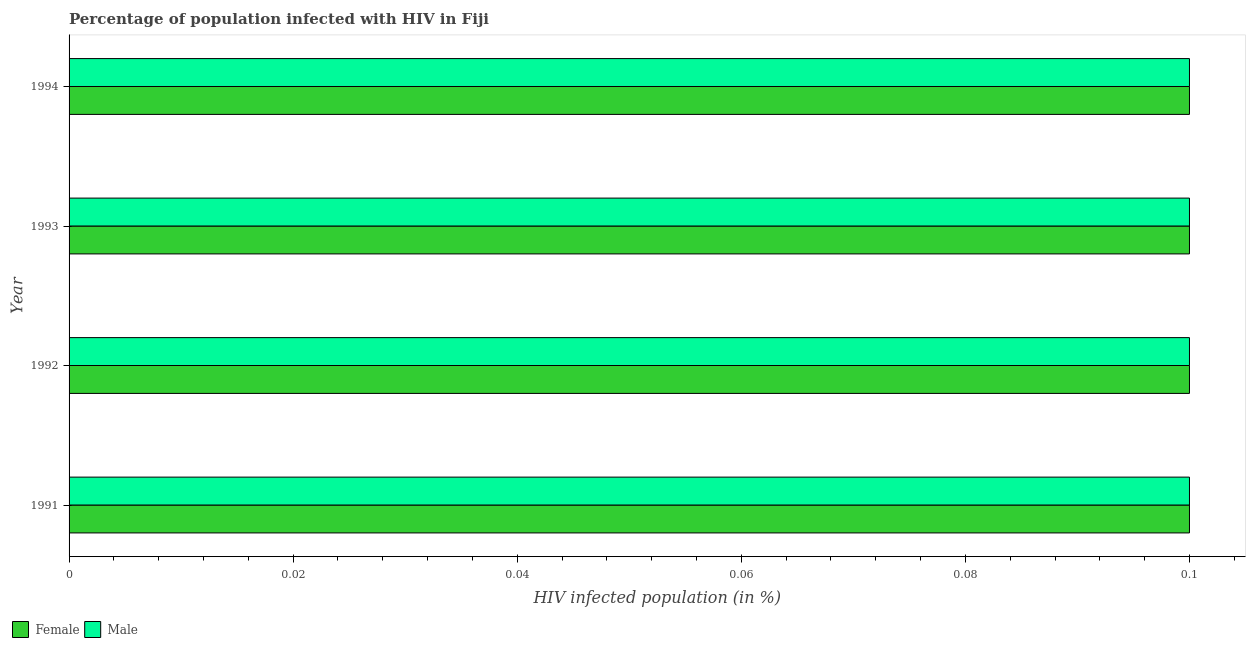How many different coloured bars are there?
Give a very brief answer. 2. Are the number of bars on each tick of the Y-axis equal?
Offer a very short reply. Yes. How many bars are there on the 3rd tick from the top?
Provide a succinct answer. 2. How many bars are there on the 1st tick from the bottom?
Provide a succinct answer. 2. What is the label of the 4th group of bars from the top?
Provide a succinct answer. 1991. In which year was the percentage of males who are infected with hiv minimum?
Ensure brevity in your answer.  1991. What is the total percentage of females who are infected with hiv in the graph?
Your answer should be very brief. 0.4. What is the difference between the percentage of females who are infected with hiv in 1992 and that in 1993?
Your response must be concise. 0. What is the difference between the percentage of females who are infected with hiv in 1994 and the percentage of males who are infected with hiv in 1993?
Give a very brief answer. 0. In the year 1994, what is the difference between the percentage of females who are infected with hiv and percentage of males who are infected with hiv?
Provide a succinct answer. 0. What is the ratio of the percentage of females who are infected with hiv in 1993 to that in 1994?
Give a very brief answer. 1. Is the difference between the percentage of females who are infected with hiv in 1992 and 1993 greater than the difference between the percentage of males who are infected with hiv in 1992 and 1993?
Make the answer very short. No. What is the difference between the highest and the lowest percentage of females who are infected with hiv?
Your answer should be compact. 0. In how many years, is the percentage of males who are infected with hiv greater than the average percentage of males who are infected with hiv taken over all years?
Offer a very short reply. 0. How many bars are there?
Offer a terse response. 8. Are all the bars in the graph horizontal?
Your response must be concise. Yes. What is the difference between two consecutive major ticks on the X-axis?
Provide a short and direct response. 0.02. Are the values on the major ticks of X-axis written in scientific E-notation?
Provide a succinct answer. No. Does the graph contain any zero values?
Give a very brief answer. No. Where does the legend appear in the graph?
Keep it short and to the point. Bottom left. How many legend labels are there?
Keep it short and to the point. 2. What is the title of the graph?
Make the answer very short. Percentage of population infected with HIV in Fiji. What is the label or title of the X-axis?
Make the answer very short. HIV infected population (in %). What is the HIV infected population (in %) of Male in 1991?
Provide a succinct answer. 0.1. What is the HIV infected population (in %) of Male in 1994?
Provide a succinct answer. 0.1. Across all years, what is the maximum HIV infected population (in %) of Female?
Provide a succinct answer. 0.1. Across all years, what is the minimum HIV infected population (in %) of Male?
Provide a succinct answer. 0.1. What is the total HIV infected population (in %) in Female in the graph?
Provide a succinct answer. 0.4. What is the difference between the HIV infected population (in %) in Male in 1991 and that in 1992?
Offer a terse response. 0. What is the difference between the HIV infected population (in %) of Female in 1991 and that in 1993?
Your answer should be very brief. 0. What is the difference between the HIV infected population (in %) in Male in 1991 and that in 1994?
Your answer should be very brief. 0. What is the difference between the HIV infected population (in %) in Male in 1992 and that in 1993?
Offer a terse response. 0. What is the difference between the HIV infected population (in %) of Male in 1993 and that in 1994?
Provide a succinct answer. 0. What is the difference between the HIV infected population (in %) in Female in 1991 and the HIV infected population (in %) in Male in 1993?
Provide a short and direct response. 0. What is the difference between the HIV infected population (in %) of Female in 1991 and the HIV infected population (in %) of Male in 1994?
Give a very brief answer. 0. What is the difference between the HIV infected population (in %) of Female in 1992 and the HIV infected population (in %) of Male in 1993?
Give a very brief answer. 0. What is the average HIV infected population (in %) of Female per year?
Provide a short and direct response. 0.1. In the year 1991, what is the difference between the HIV infected population (in %) of Female and HIV infected population (in %) of Male?
Your answer should be very brief. 0. What is the ratio of the HIV infected population (in %) of Male in 1991 to that in 1992?
Offer a very short reply. 1. What is the ratio of the HIV infected population (in %) of Male in 1991 to that in 1993?
Your answer should be compact. 1. What is the ratio of the HIV infected population (in %) of Male in 1991 to that in 1994?
Give a very brief answer. 1. What is the ratio of the HIV infected population (in %) of Female in 1992 to that in 1994?
Offer a terse response. 1. What is the ratio of the HIV infected population (in %) of Male in 1992 to that in 1994?
Provide a succinct answer. 1. What is the difference between the highest and the second highest HIV infected population (in %) of Male?
Your answer should be compact. 0. What is the difference between the highest and the lowest HIV infected population (in %) of Male?
Make the answer very short. 0. 